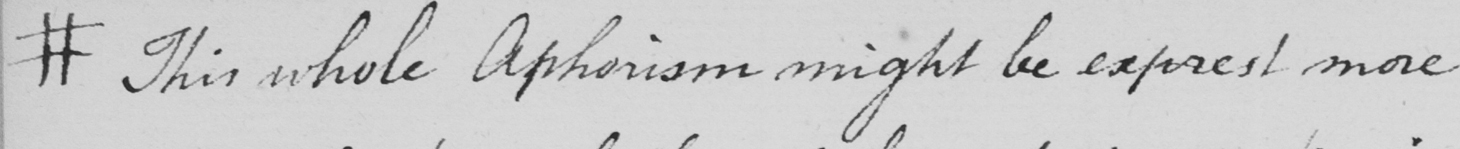Can you tell me what this handwritten text says? #  This whole Aphorism might be exprest more 